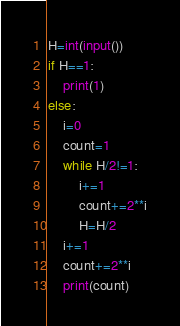Convert code to text. <code><loc_0><loc_0><loc_500><loc_500><_Python_>H=int(input())
if H==1:
    print(1)
else:
    i=0
    count=1
    while H/2!=1:
        i+=1
        count+=2**i
        H=H/2
    i+=1
    count+=2**i
    print(count)</code> 